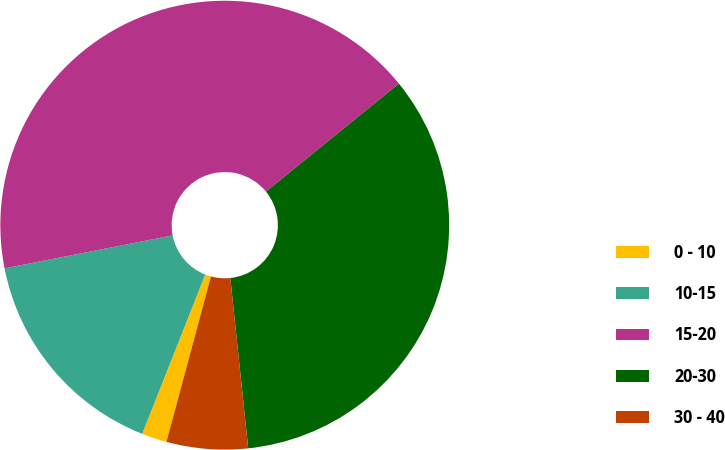Convert chart to OTSL. <chart><loc_0><loc_0><loc_500><loc_500><pie_chart><fcel>0 - 10<fcel>10-15<fcel>15-20<fcel>20-30<fcel>30 - 40<nl><fcel>1.81%<fcel>15.92%<fcel>42.22%<fcel>34.19%<fcel>5.85%<nl></chart> 